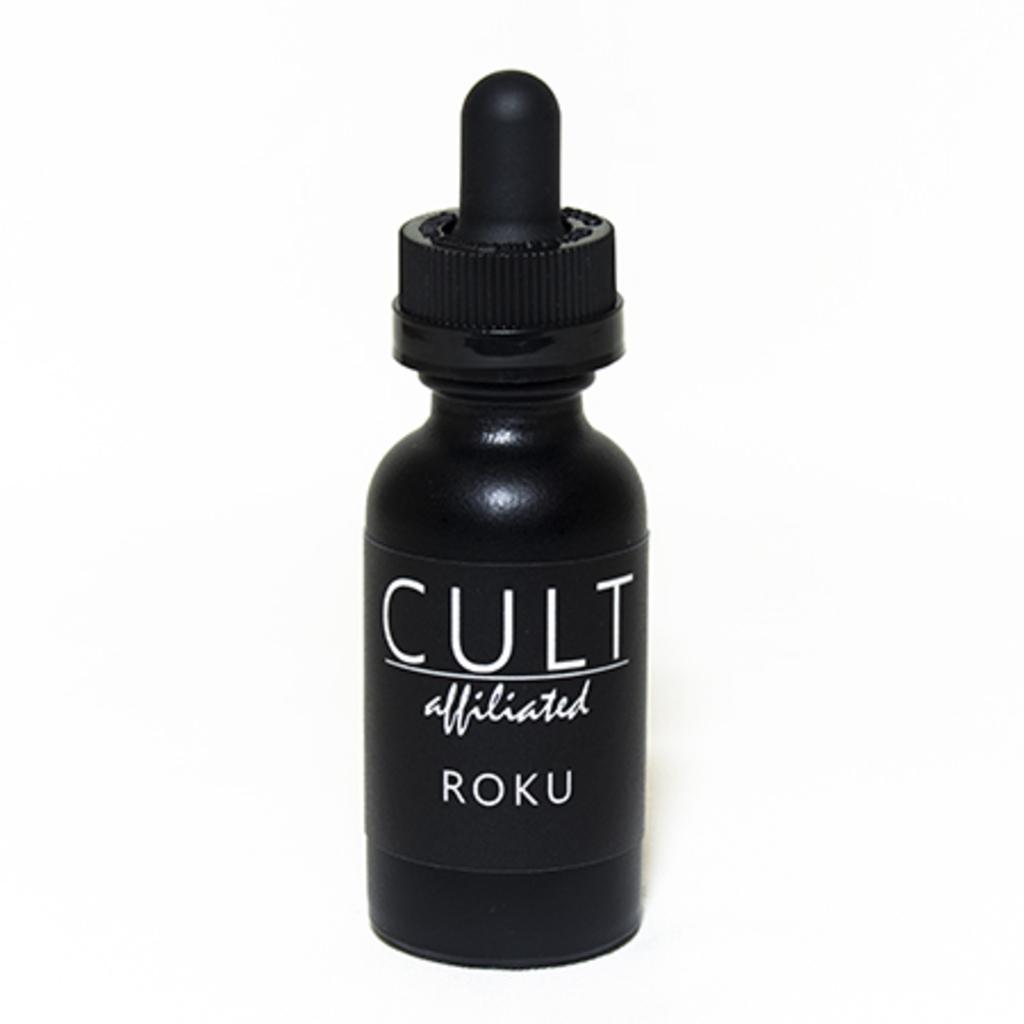What is the brand of the product?
Keep it short and to the point. Cult. 